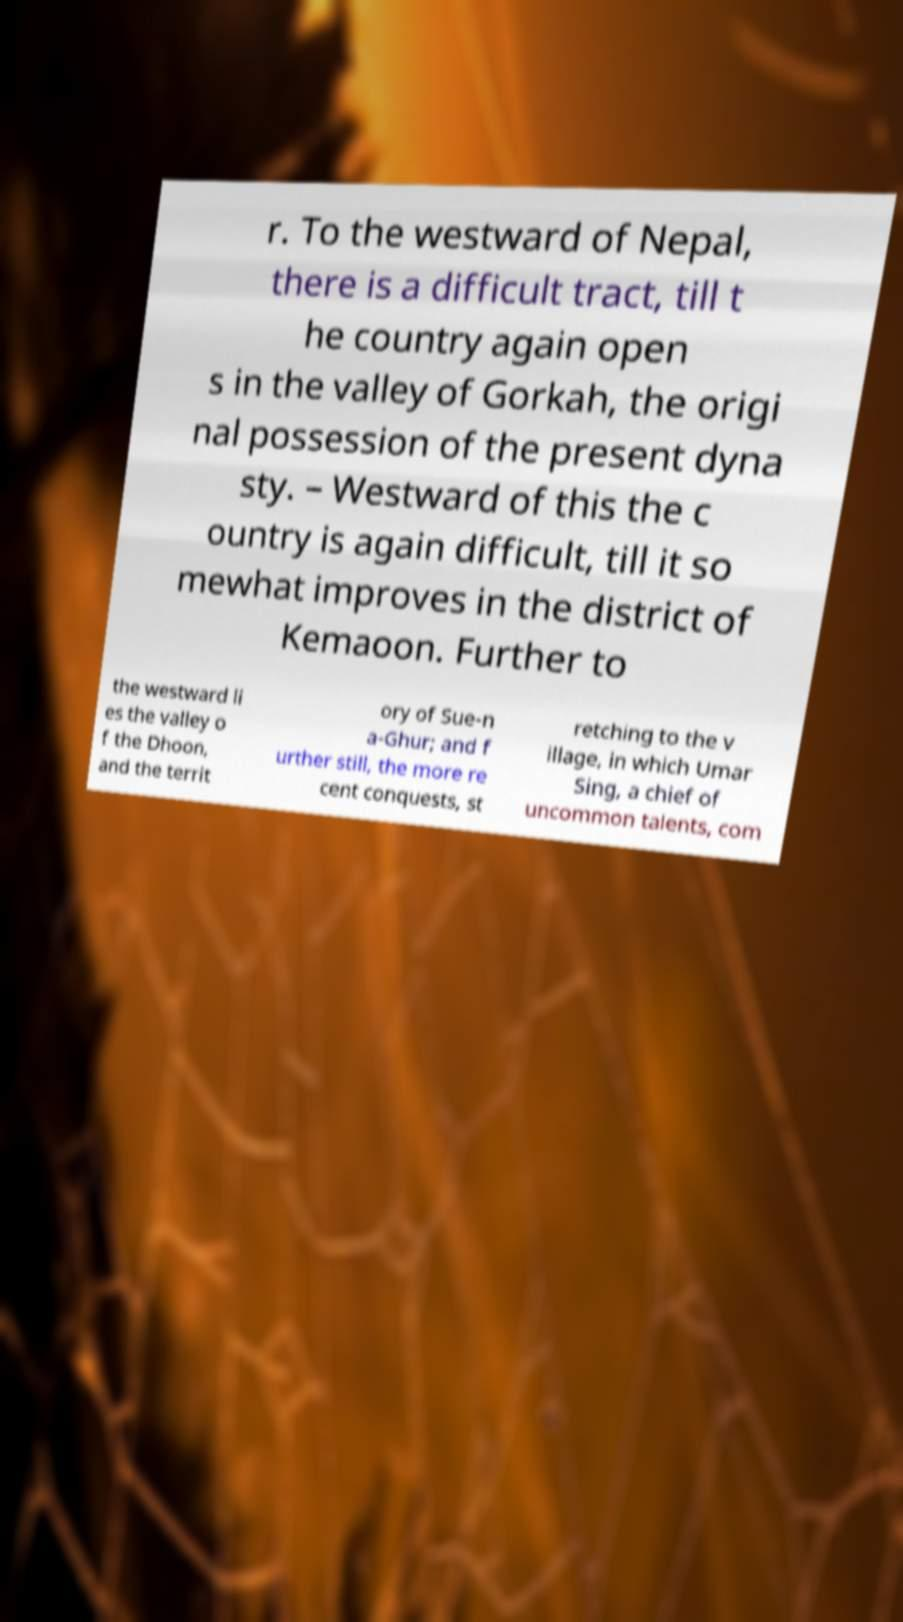Please identify and transcribe the text found in this image. r. To the westward of Nepal, there is a difficult tract, till t he country again open s in the valley of Gorkah, the origi nal possession of the present dyna sty. – Westward of this the c ountry is again difficult, till it so mewhat improves in the district of Kemaoon. Further to the westward li es the valley o f the Dhoon, and the territ ory of Sue-n a-Ghur; and f urther still, the more re cent conquests, st retching to the v illage, in which Umar Sing, a chief of uncommon talents, com 